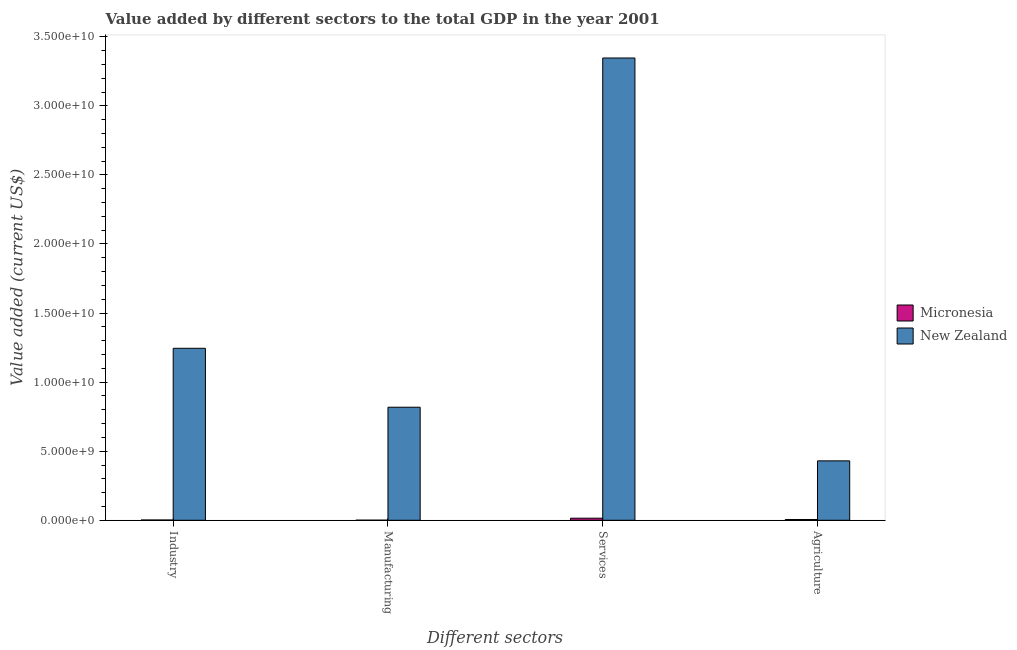How many groups of bars are there?
Provide a succinct answer. 4. How many bars are there on the 4th tick from the right?
Your answer should be compact. 2. What is the label of the 3rd group of bars from the left?
Ensure brevity in your answer.  Services. What is the value added by services sector in New Zealand?
Give a very brief answer. 3.35e+1. Across all countries, what is the maximum value added by services sector?
Ensure brevity in your answer.  3.35e+1. Across all countries, what is the minimum value added by manufacturing sector?
Offer a terse response. 4.61e+06. In which country was the value added by industrial sector maximum?
Your answer should be very brief. New Zealand. In which country was the value added by industrial sector minimum?
Give a very brief answer. Micronesia. What is the total value added by manufacturing sector in the graph?
Offer a very short reply. 8.19e+09. What is the difference between the value added by manufacturing sector in Micronesia and that in New Zealand?
Offer a very short reply. -8.18e+09. What is the difference between the value added by industrial sector in Micronesia and the value added by services sector in New Zealand?
Make the answer very short. -3.34e+1. What is the average value added by agricultural sector per country?
Offer a very short reply. 2.18e+09. What is the difference between the value added by manufacturing sector and value added by agricultural sector in New Zealand?
Your answer should be very brief. 3.88e+09. In how many countries, is the value added by agricultural sector greater than 18000000000 US$?
Ensure brevity in your answer.  0. What is the ratio of the value added by industrial sector in New Zealand to that in Micronesia?
Provide a succinct answer. 619.04. Is the value added by agricultural sector in Micronesia less than that in New Zealand?
Provide a succinct answer. Yes. What is the difference between the highest and the second highest value added by manufacturing sector?
Ensure brevity in your answer.  8.18e+09. What is the difference between the highest and the lowest value added by services sector?
Your response must be concise. 3.33e+1. Is the sum of the value added by manufacturing sector in New Zealand and Micronesia greater than the maximum value added by industrial sector across all countries?
Keep it short and to the point. No. What does the 2nd bar from the left in Services represents?
Give a very brief answer. New Zealand. What does the 1st bar from the right in Industry represents?
Your answer should be very brief. New Zealand. Are all the bars in the graph horizontal?
Your answer should be very brief. No. How many countries are there in the graph?
Offer a very short reply. 2. Does the graph contain any zero values?
Make the answer very short. No. Does the graph contain grids?
Your answer should be very brief. No. How many legend labels are there?
Make the answer very short. 2. How are the legend labels stacked?
Provide a succinct answer. Vertical. What is the title of the graph?
Offer a terse response. Value added by different sectors to the total GDP in the year 2001. Does "South Asia" appear as one of the legend labels in the graph?
Provide a short and direct response. No. What is the label or title of the X-axis?
Provide a short and direct response. Different sectors. What is the label or title of the Y-axis?
Make the answer very short. Value added (current US$). What is the Value added (current US$) of Micronesia in Industry?
Offer a very short reply. 2.01e+07. What is the Value added (current US$) of New Zealand in Industry?
Give a very brief answer. 1.24e+1. What is the Value added (current US$) in Micronesia in Manufacturing?
Offer a very short reply. 4.61e+06. What is the Value added (current US$) in New Zealand in Manufacturing?
Make the answer very short. 8.18e+09. What is the Value added (current US$) in Micronesia in Services?
Your answer should be very brief. 1.50e+08. What is the Value added (current US$) in New Zealand in Services?
Make the answer very short. 3.35e+1. What is the Value added (current US$) in Micronesia in Agriculture?
Offer a very short reply. 5.60e+07. What is the Value added (current US$) in New Zealand in Agriculture?
Provide a short and direct response. 4.30e+09. Across all Different sectors, what is the maximum Value added (current US$) in Micronesia?
Give a very brief answer. 1.50e+08. Across all Different sectors, what is the maximum Value added (current US$) of New Zealand?
Offer a terse response. 3.35e+1. Across all Different sectors, what is the minimum Value added (current US$) in Micronesia?
Provide a succinct answer. 4.61e+06. Across all Different sectors, what is the minimum Value added (current US$) of New Zealand?
Provide a short and direct response. 4.30e+09. What is the total Value added (current US$) of Micronesia in the graph?
Your response must be concise. 2.31e+08. What is the total Value added (current US$) of New Zealand in the graph?
Offer a terse response. 5.84e+1. What is the difference between the Value added (current US$) in Micronesia in Industry and that in Manufacturing?
Offer a terse response. 1.55e+07. What is the difference between the Value added (current US$) in New Zealand in Industry and that in Manufacturing?
Make the answer very short. 4.27e+09. What is the difference between the Value added (current US$) of Micronesia in Industry and that in Services?
Provide a succinct answer. -1.30e+08. What is the difference between the Value added (current US$) of New Zealand in Industry and that in Services?
Offer a very short reply. -2.10e+1. What is the difference between the Value added (current US$) of Micronesia in Industry and that in Agriculture?
Your response must be concise. -3.59e+07. What is the difference between the Value added (current US$) of New Zealand in Industry and that in Agriculture?
Ensure brevity in your answer.  8.15e+09. What is the difference between the Value added (current US$) of Micronesia in Manufacturing and that in Services?
Make the answer very short. -1.46e+08. What is the difference between the Value added (current US$) in New Zealand in Manufacturing and that in Services?
Ensure brevity in your answer.  -2.53e+1. What is the difference between the Value added (current US$) in Micronesia in Manufacturing and that in Agriculture?
Make the answer very short. -5.14e+07. What is the difference between the Value added (current US$) of New Zealand in Manufacturing and that in Agriculture?
Your response must be concise. 3.88e+09. What is the difference between the Value added (current US$) in Micronesia in Services and that in Agriculture?
Provide a succinct answer. 9.44e+07. What is the difference between the Value added (current US$) in New Zealand in Services and that in Agriculture?
Provide a short and direct response. 2.92e+1. What is the difference between the Value added (current US$) in Micronesia in Industry and the Value added (current US$) in New Zealand in Manufacturing?
Offer a terse response. -8.16e+09. What is the difference between the Value added (current US$) of Micronesia in Industry and the Value added (current US$) of New Zealand in Services?
Your answer should be compact. -3.34e+1. What is the difference between the Value added (current US$) of Micronesia in Industry and the Value added (current US$) of New Zealand in Agriculture?
Offer a terse response. -4.28e+09. What is the difference between the Value added (current US$) of Micronesia in Manufacturing and the Value added (current US$) of New Zealand in Services?
Your answer should be compact. -3.35e+1. What is the difference between the Value added (current US$) in Micronesia in Manufacturing and the Value added (current US$) in New Zealand in Agriculture?
Your response must be concise. -4.30e+09. What is the difference between the Value added (current US$) in Micronesia in Services and the Value added (current US$) in New Zealand in Agriculture?
Provide a short and direct response. -4.15e+09. What is the average Value added (current US$) of Micronesia per Different sectors?
Provide a succinct answer. 5.78e+07. What is the average Value added (current US$) of New Zealand per Different sectors?
Keep it short and to the point. 1.46e+1. What is the difference between the Value added (current US$) of Micronesia and Value added (current US$) of New Zealand in Industry?
Your answer should be compact. -1.24e+1. What is the difference between the Value added (current US$) in Micronesia and Value added (current US$) in New Zealand in Manufacturing?
Keep it short and to the point. -8.18e+09. What is the difference between the Value added (current US$) in Micronesia and Value added (current US$) in New Zealand in Services?
Provide a short and direct response. -3.33e+1. What is the difference between the Value added (current US$) of Micronesia and Value added (current US$) of New Zealand in Agriculture?
Ensure brevity in your answer.  -4.24e+09. What is the ratio of the Value added (current US$) of Micronesia in Industry to that in Manufacturing?
Provide a short and direct response. 4.36. What is the ratio of the Value added (current US$) of New Zealand in Industry to that in Manufacturing?
Make the answer very short. 1.52. What is the ratio of the Value added (current US$) in Micronesia in Industry to that in Services?
Offer a terse response. 0.13. What is the ratio of the Value added (current US$) in New Zealand in Industry to that in Services?
Offer a terse response. 0.37. What is the ratio of the Value added (current US$) of Micronesia in Industry to that in Agriculture?
Keep it short and to the point. 0.36. What is the ratio of the Value added (current US$) of New Zealand in Industry to that in Agriculture?
Provide a succinct answer. 2.9. What is the ratio of the Value added (current US$) of Micronesia in Manufacturing to that in Services?
Make the answer very short. 0.03. What is the ratio of the Value added (current US$) in New Zealand in Manufacturing to that in Services?
Keep it short and to the point. 0.24. What is the ratio of the Value added (current US$) in Micronesia in Manufacturing to that in Agriculture?
Give a very brief answer. 0.08. What is the ratio of the Value added (current US$) in New Zealand in Manufacturing to that in Agriculture?
Ensure brevity in your answer.  1.9. What is the ratio of the Value added (current US$) in Micronesia in Services to that in Agriculture?
Keep it short and to the point. 2.68. What is the ratio of the Value added (current US$) in New Zealand in Services to that in Agriculture?
Provide a short and direct response. 7.78. What is the difference between the highest and the second highest Value added (current US$) in Micronesia?
Your response must be concise. 9.44e+07. What is the difference between the highest and the second highest Value added (current US$) in New Zealand?
Provide a short and direct response. 2.10e+1. What is the difference between the highest and the lowest Value added (current US$) in Micronesia?
Provide a short and direct response. 1.46e+08. What is the difference between the highest and the lowest Value added (current US$) in New Zealand?
Your response must be concise. 2.92e+1. 